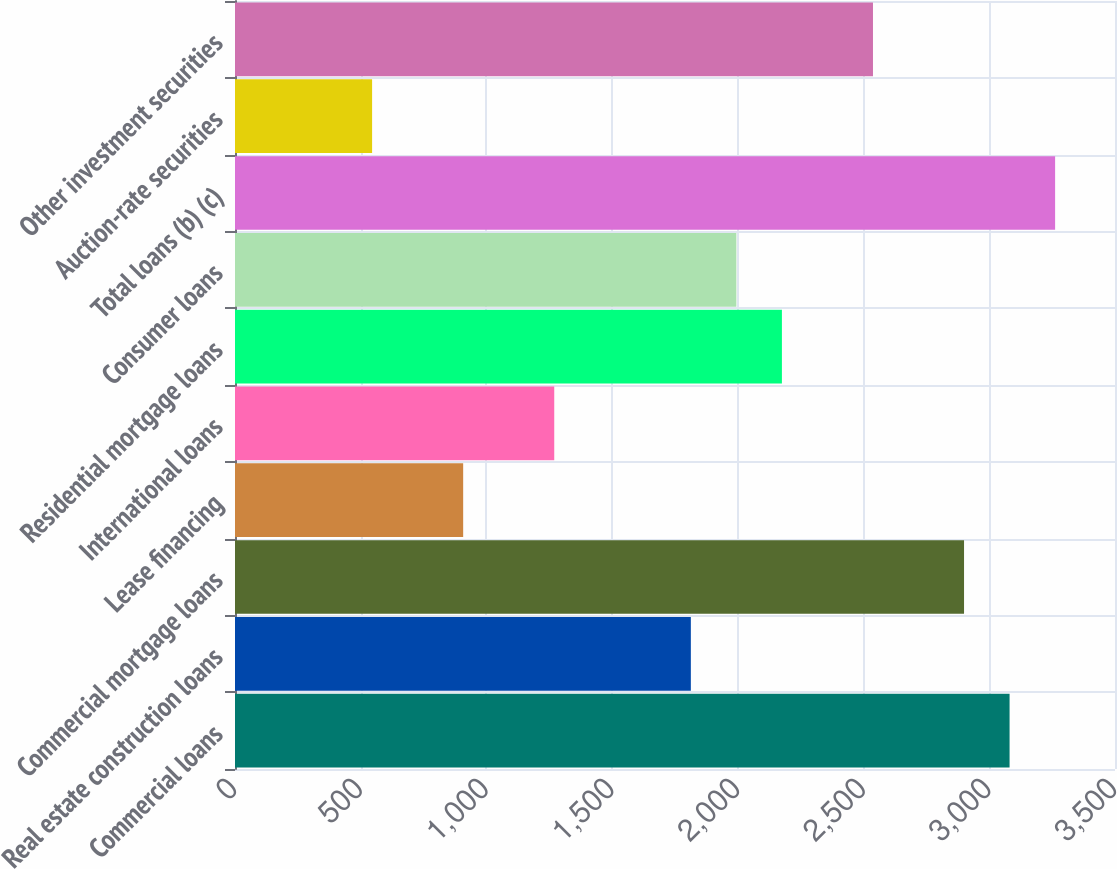<chart> <loc_0><loc_0><loc_500><loc_500><bar_chart><fcel>Commercial loans<fcel>Real estate construction loans<fcel>Commercial mortgage loans<fcel>Lease financing<fcel>International loans<fcel>Residential mortgage loans<fcel>Consumer loans<fcel>Total loans (b) (c)<fcel>Auction-rate securities<fcel>Other investment securities<nl><fcel>3080.7<fcel>1813<fcel>2899.6<fcel>907.5<fcel>1269.7<fcel>2175.2<fcel>1994.1<fcel>3261.8<fcel>545.3<fcel>2537.4<nl></chart> 